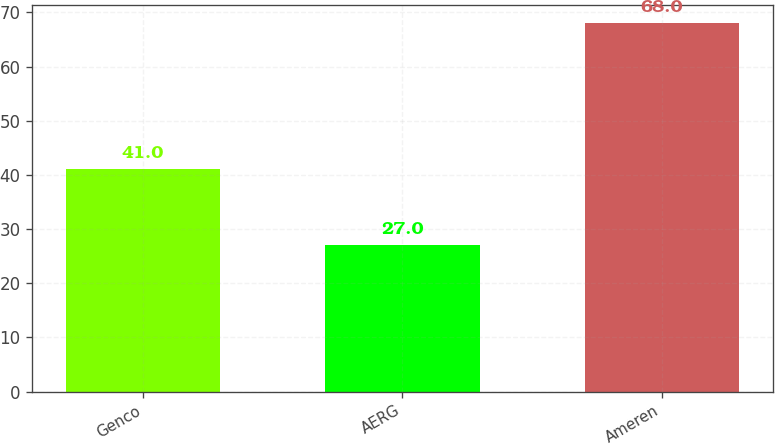<chart> <loc_0><loc_0><loc_500><loc_500><bar_chart><fcel>Genco<fcel>AERG<fcel>Ameren<nl><fcel>41<fcel>27<fcel>68<nl></chart> 